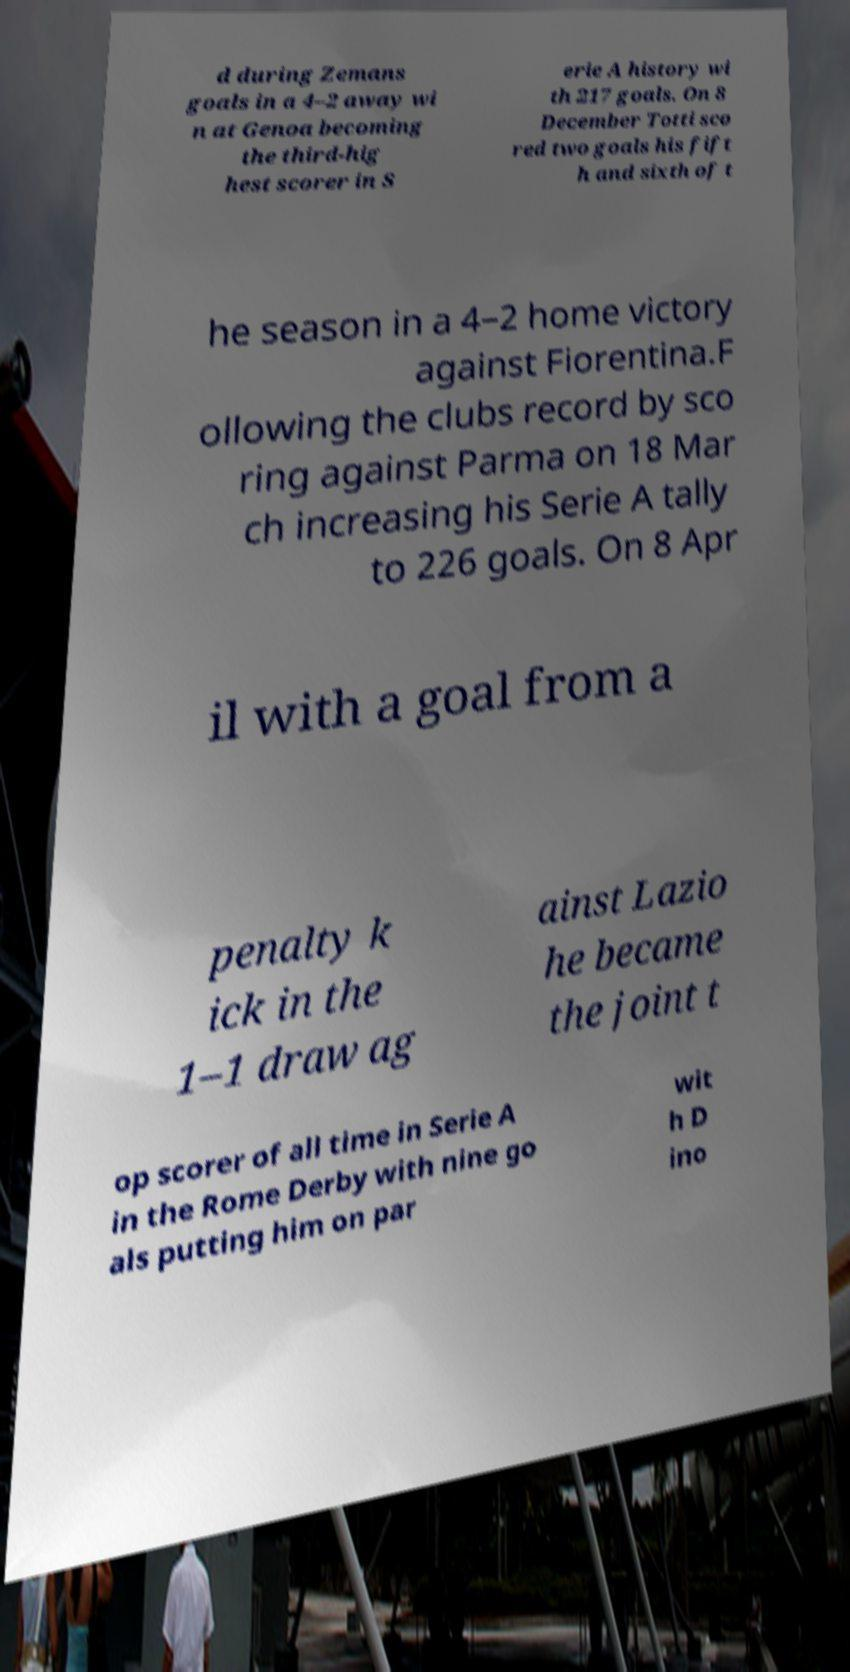Could you assist in decoding the text presented in this image and type it out clearly? d during Zemans goals in a 4–2 away wi n at Genoa becoming the third-hig hest scorer in S erie A history wi th 217 goals. On 8 December Totti sco red two goals his fift h and sixth of t he season in a 4–2 home victory against Fiorentina.F ollowing the clubs record by sco ring against Parma on 18 Mar ch increasing his Serie A tally to 226 goals. On 8 Apr il with a goal from a penalty k ick in the 1–1 draw ag ainst Lazio he became the joint t op scorer of all time in Serie A in the Rome Derby with nine go als putting him on par wit h D ino 